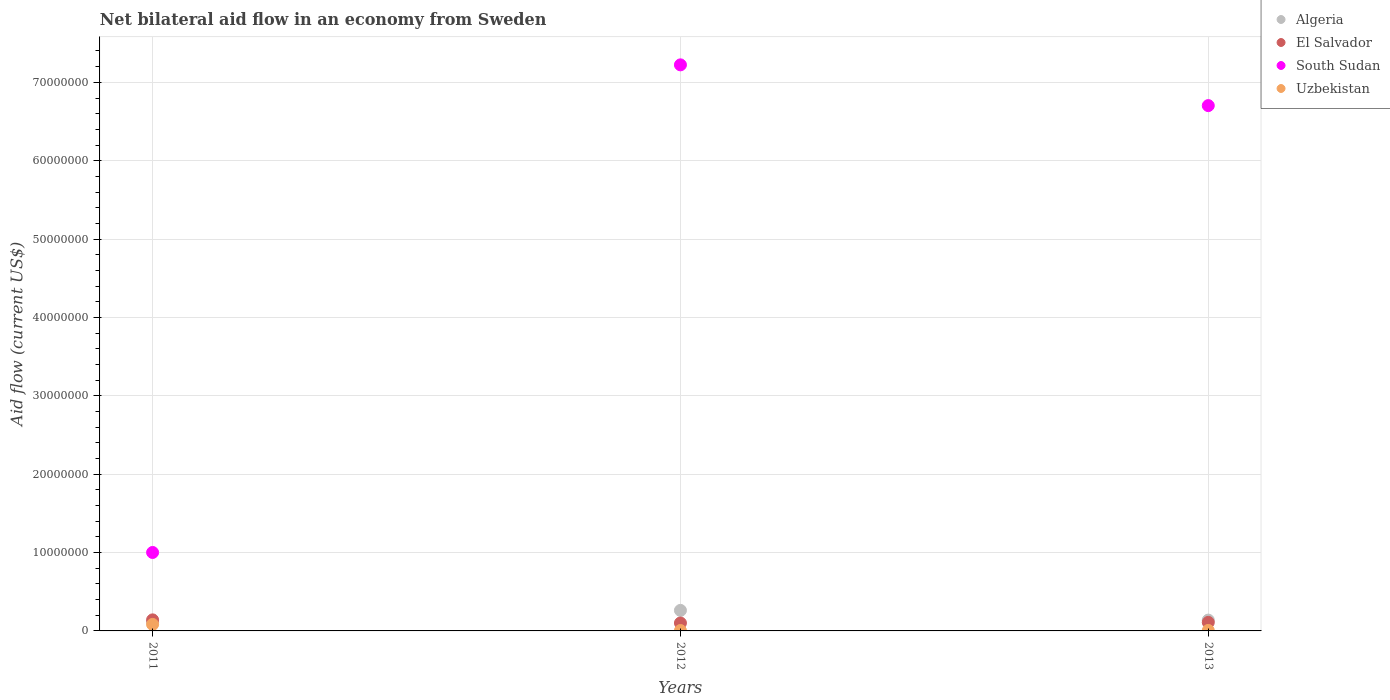Is the number of dotlines equal to the number of legend labels?
Your response must be concise. Yes. What is the net bilateral aid flow in South Sudan in 2011?
Your answer should be very brief. 1.00e+07. Across all years, what is the maximum net bilateral aid flow in Uzbekistan?
Your answer should be compact. 8.30e+05. Across all years, what is the minimum net bilateral aid flow in South Sudan?
Your answer should be very brief. 1.00e+07. In which year was the net bilateral aid flow in Uzbekistan maximum?
Provide a succinct answer. 2011. In which year was the net bilateral aid flow in Uzbekistan minimum?
Ensure brevity in your answer.  2012. What is the total net bilateral aid flow in El Salvador in the graph?
Ensure brevity in your answer.  3.51e+06. What is the difference between the net bilateral aid flow in Algeria in 2012 and that in 2013?
Offer a terse response. 1.24e+06. What is the average net bilateral aid flow in South Sudan per year?
Give a very brief answer. 4.98e+07. In how many years, is the net bilateral aid flow in Algeria greater than 46000000 US$?
Your response must be concise. 0. What is the ratio of the net bilateral aid flow in Algeria in 2011 to that in 2013?
Give a very brief answer. 0.78. What is the difference between the highest and the second highest net bilateral aid flow in South Sudan?
Ensure brevity in your answer.  5.20e+06. What is the difference between the highest and the lowest net bilateral aid flow in South Sudan?
Offer a terse response. 6.22e+07. In how many years, is the net bilateral aid flow in El Salvador greater than the average net bilateral aid flow in El Salvador taken over all years?
Make the answer very short. 1. Is it the case that in every year, the sum of the net bilateral aid flow in Algeria and net bilateral aid flow in Uzbekistan  is greater than the sum of net bilateral aid flow in South Sudan and net bilateral aid flow in El Salvador?
Offer a terse response. No. Is the net bilateral aid flow in South Sudan strictly less than the net bilateral aid flow in Algeria over the years?
Offer a very short reply. No. What is the difference between two consecutive major ticks on the Y-axis?
Keep it short and to the point. 1.00e+07. Does the graph contain any zero values?
Provide a short and direct response. No. Where does the legend appear in the graph?
Give a very brief answer. Top right. How many legend labels are there?
Offer a very short reply. 4. What is the title of the graph?
Give a very brief answer. Net bilateral aid flow in an economy from Sweden. What is the label or title of the Y-axis?
Ensure brevity in your answer.  Aid flow (current US$). What is the Aid flow (current US$) in Algeria in 2011?
Your response must be concise. 1.08e+06. What is the Aid flow (current US$) in El Salvador in 2011?
Your response must be concise. 1.41e+06. What is the Aid flow (current US$) of South Sudan in 2011?
Ensure brevity in your answer.  1.00e+07. What is the Aid flow (current US$) of Uzbekistan in 2011?
Make the answer very short. 8.30e+05. What is the Aid flow (current US$) of Algeria in 2012?
Give a very brief answer. 2.62e+06. What is the Aid flow (current US$) in El Salvador in 2012?
Offer a terse response. 1.01e+06. What is the Aid flow (current US$) in South Sudan in 2012?
Provide a short and direct response. 7.22e+07. What is the Aid flow (current US$) in Algeria in 2013?
Make the answer very short. 1.38e+06. What is the Aid flow (current US$) of El Salvador in 2013?
Offer a very short reply. 1.09e+06. What is the Aid flow (current US$) of South Sudan in 2013?
Your answer should be very brief. 6.70e+07. What is the Aid flow (current US$) of Uzbekistan in 2013?
Offer a very short reply. 6.00e+04. Across all years, what is the maximum Aid flow (current US$) in Algeria?
Keep it short and to the point. 2.62e+06. Across all years, what is the maximum Aid flow (current US$) in El Salvador?
Give a very brief answer. 1.41e+06. Across all years, what is the maximum Aid flow (current US$) of South Sudan?
Offer a terse response. 7.22e+07. Across all years, what is the maximum Aid flow (current US$) of Uzbekistan?
Your response must be concise. 8.30e+05. Across all years, what is the minimum Aid flow (current US$) of Algeria?
Your answer should be very brief. 1.08e+06. Across all years, what is the minimum Aid flow (current US$) of El Salvador?
Give a very brief answer. 1.01e+06. Across all years, what is the minimum Aid flow (current US$) of South Sudan?
Your answer should be very brief. 1.00e+07. Across all years, what is the minimum Aid flow (current US$) in Uzbekistan?
Your answer should be very brief. 5.00e+04. What is the total Aid flow (current US$) of Algeria in the graph?
Make the answer very short. 5.08e+06. What is the total Aid flow (current US$) in El Salvador in the graph?
Ensure brevity in your answer.  3.51e+06. What is the total Aid flow (current US$) in South Sudan in the graph?
Ensure brevity in your answer.  1.49e+08. What is the total Aid flow (current US$) in Uzbekistan in the graph?
Ensure brevity in your answer.  9.40e+05. What is the difference between the Aid flow (current US$) of Algeria in 2011 and that in 2012?
Provide a succinct answer. -1.54e+06. What is the difference between the Aid flow (current US$) of South Sudan in 2011 and that in 2012?
Make the answer very short. -6.22e+07. What is the difference between the Aid flow (current US$) of Uzbekistan in 2011 and that in 2012?
Provide a short and direct response. 7.80e+05. What is the difference between the Aid flow (current US$) of El Salvador in 2011 and that in 2013?
Keep it short and to the point. 3.20e+05. What is the difference between the Aid flow (current US$) of South Sudan in 2011 and that in 2013?
Provide a succinct answer. -5.70e+07. What is the difference between the Aid flow (current US$) of Uzbekistan in 2011 and that in 2013?
Make the answer very short. 7.70e+05. What is the difference between the Aid flow (current US$) of Algeria in 2012 and that in 2013?
Offer a very short reply. 1.24e+06. What is the difference between the Aid flow (current US$) in South Sudan in 2012 and that in 2013?
Provide a succinct answer. 5.20e+06. What is the difference between the Aid flow (current US$) of Uzbekistan in 2012 and that in 2013?
Offer a very short reply. -10000. What is the difference between the Aid flow (current US$) in Algeria in 2011 and the Aid flow (current US$) in El Salvador in 2012?
Make the answer very short. 7.00e+04. What is the difference between the Aid flow (current US$) in Algeria in 2011 and the Aid flow (current US$) in South Sudan in 2012?
Give a very brief answer. -7.12e+07. What is the difference between the Aid flow (current US$) of Algeria in 2011 and the Aid flow (current US$) of Uzbekistan in 2012?
Offer a very short reply. 1.03e+06. What is the difference between the Aid flow (current US$) of El Salvador in 2011 and the Aid flow (current US$) of South Sudan in 2012?
Provide a short and direct response. -7.08e+07. What is the difference between the Aid flow (current US$) in El Salvador in 2011 and the Aid flow (current US$) in Uzbekistan in 2012?
Make the answer very short. 1.36e+06. What is the difference between the Aid flow (current US$) of South Sudan in 2011 and the Aid flow (current US$) of Uzbekistan in 2012?
Your answer should be compact. 9.96e+06. What is the difference between the Aid flow (current US$) of Algeria in 2011 and the Aid flow (current US$) of South Sudan in 2013?
Give a very brief answer. -6.60e+07. What is the difference between the Aid flow (current US$) of Algeria in 2011 and the Aid flow (current US$) of Uzbekistan in 2013?
Provide a succinct answer. 1.02e+06. What is the difference between the Aid flow (current US$) of El Salvador in 2011 and the Aid flow (current US$) of South Sudan in 2013?
Ensure brevity in your answer.  -6.56e+07. What is the difference between the Aid flow (current US$) of El Salvador in 2011 and the Aid flow (current US$) of Uzbekistan in 2013?
Your answer should be very brief. 1.35e+06. What is the difference between the Aid flow (current US$) of South Sudan in 2011 and the Aid flow (current US$) of Uzbekistan in 2013?
Make the answer very short. 9.95e+06. What is the difference between the Aid flow (current US$) of Algeria in 2012 and the Aid flow (current US$) of El Salvador in 2013?
Your answer should be very brief. 1.53e+06. What is the difference between the Aid flow (current US$) of Algeria in 2012 and the Aid flow (current US$) of South Sudan in 2013?
Your answer should be compact. -6.44e+07. What is the difference between the Aid flow (current US$) of Algeria in 2012 and the Aid flow (current US$) of Uzbekistan in 2013?
Your response must be concise. 2.56e+06. What is the difference between the Aid flow (current US$) in El Salvador in 2012 and the Aid flow (current US$) in South Sudan in 2013?
Give a very brief answer. -6.60e+07. What is the difference between the Aid flow (current US$) of El Salvador in 2012 and the Aid flow (current US$) of Uzbekistan in 2013?
Your response must be concise. 9.50e+05. What is the difference between the Aid flow (current US$) in South Sudan in 2012 and the Aid flow (current US$) in Uzbekistan in 2013?
Give a very brief answer. 7.22e+07. What is the average Aid flow (current US$) of Algeria per year?
Offer a very short reply. 1.69e+06. What is the average Aid flow (current US$) in El Salvador per year?
Keep it short and to the point. 1.17e+06. What is the average Aid flow (current US$) of South Sudan per year?
Give a very brief answer. 4.98e+07. What is the average Aid flow (current US$) in Uzbekistan per year?
Your response must be concise. 3.13e+05. In the year 2011, what is the difference between the Aid flow (current US$) of Algeria and Aid flow (current US$) of El Salvador?
Provide a short and direct response. -3.30e+05. In the year 2011, what is the difference between the Aid flow (current US$) in Algeria and Aid flow (current US$) in South Sudan?
Your response must be concise. -8.93e+06. In the year 2011, what is the difference between the Aid flow (current US$) of Algeria and Aid flow (current US$) of Uzbekistan?
Ensure brevity in your answer.  2.50e+05. In the year 2011, what is the difference between the Aid flow (current US$) of El Salvador and Aid flow (current US$) of South Sudan?
Offer a very short reply. -8.60e+06. In the year 2011, what is the difference between the Aid flow (current US$) in El Salvador and Aid flow (current US$) in Uzbekistan?
Provide a succinct answer. 5.80e+05. In the year 2011, what is the difference between the Aid flow (current US$) in South Sudan and Aid flow (current US$) in Uzbekistan?
Your answer should be very brief. 9.18e+06. In the year 2012, what is the difference between the Aid flow (current US$) in Algeria and Aid flow (current US$) in El Salvador?
Keep it short and to the point. 1.61e+06. In the year 2012, what is the difference between the Aid flow (current US$) in Algeria and Aid flow (current US$) in South Sudan?
Make the answer very short. -6.96e+07. In the year 2012, what is the difference between the Aid flow (current US$) of Algeria and Aid flow (current US$) of Uzbekistan?
Give a very brief answer. 2.57e+06. In the year 2012, what is the difference between the Aid flow (current US$) of El Salvador and Aid flow (current US$) of South Sudan?
Provide a short and direct response. -7.12e+07. In the year 2012, what is the difference between the Aid flow (current US$) in El Salvador and Aid flow (current US$) in Uzbekistan?
Offer a very short reply. 9.60e+05. In the year 2012, what is the difference between the Aid flow (current US$) in South Sudan and Aid flow (current US$) in Uzbekistan?
Your answer should be very brief. 7.22e+07. In the year 2013, what is the difference between the Aid flow (current US$) of Algeria and Aid flow (current US$) of El Salvador?
Provide a succinct answer. 2.90e+05. In the year 2013, what is the difference between the Aid flow (current US$) of Algeria and Aid flow (current US$) of South Sudan?
Make the answer very short. -6.56e+07. In the year 2013, what is the difference between the Aid flow (current US$) in Algeria and Aid flow (current US$) in Uzbekistan?
Offer a terse response. 1.32e+06. In the year 2013, what is the difference between the Aid flow (current US$) of El Salvador and Aid flow (current US$) of South Sudan?
Provide a short and direct response. -6.59e+07. In the year 2013, what is the difference between the Aid flow (current US$) in El Salvador and Aid flow (current US$) in Uzbekistan?
Provide a short and direct response. 1.03e+06. In the year 2013, what is the difference between the Aid flow (current US$) in South Sudan and Aid flow (current US$) in Uzbekistan?
Your answer should be very brief. 6.70e+07. What is the ratio of the Aid flow (current US$) of Algeria in 2011 to that in 2012?
Your answer should be very brief. 0.41. What is the ratio of the Aid flow (current US$) in El Salvador in 2011 to that in 2012?
Ensure brevity in your answer.  1.4. What is the ratio of the Aid flow (current US$) of South Sudan in 2011 to that in 2012?
Provide a succinct answer. 0.14. What is the ratio of the Aid flow (current US$) in Uzbekistan in 2011 to that in 2012?
Make the answer very short. 16.6. What is the ratio of the Aid flow (current US$) in Algeria in 2011 to that in 2013?
Your response must be concise. 0.78. What is the ratio of the Aid flow (current US$) of El Salvador in 2011 to that in 2013?
Provide a succinct answer. 1.29. What is the ratio of the Aid flow (current US$) in South Sudan in 2011 to that in 2013?
Keep it short and to the point. 0.15. What is the ratio of the Aid flow (current US$) in Uzbekistan in 2011 to that in 2013?
Provide a short and direct response. 13.83. What is the ratio of the Aid flow (current US$) of Algeria in 2012 to that in 2013?
Make the answer very short. 1.9. What is the ratio of the Aid flow (current US$) in El Salvador in 2012 to that in 2013?
Your answer should be very brief. 0.93. What is the ratio of the Aid flow (current US$) of South Sudan in 2012 to that in 2013?
Give a very brief answer. 1.08. What is the ratio of the Aid flow (current US$) in Uzbekistan in 2012 to that in 2013?
Your response must be concise. 0.83. What is the difference between the highest and the second highest Aid flow (current US$) in Algeria?
Keep it short and to the point. 1.24e+06. What is the difference between the highest and the second highest Aid flow (current US$) in South Sudan?
Give a very brief answer. 5.20e+06. What is the difference between the highest and the second highest Aid flow (current US$) of Uzbekistan?
Offer a very short reply. 7.70e+05. What is the difference between the highest and the lowest Aid flow (current US$) of Algeria?
Make the answer very short. 1.54e+06. What is the difference between the highest and the lowest Aid flow (current US$) in South Sudan?
Your answer should be very brief. 6.22e+07. What is the difference between the highest and the lowest Aid flow (current US$) of Uzbekistan?
Ensure brevity in your answer.  7.80e+05. 